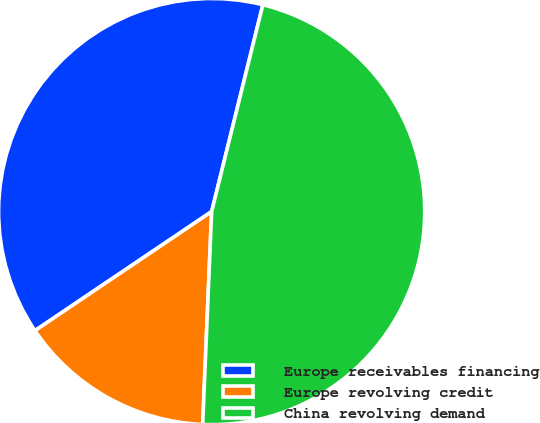<chart> <loc_0><loc_0><loc_500><loc_500><pie_chart><fcel>Europe receivables financing<fcel>Europe revolving credit<fcel>China revolving demand<nl><fcel>38.3%<fcel>14.89%<fcel>46.81%<nl></chart> 